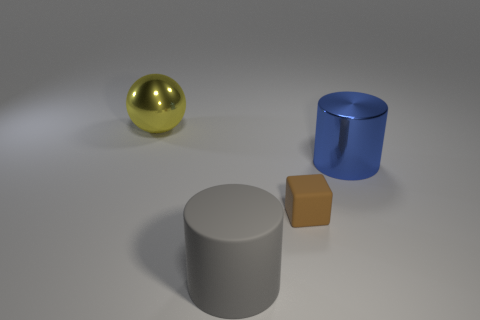Are there any other things that are the same shape as the tiny object?
Make the answer very short. No. Are there any other things that are the same size as the brown cube?
Offer a very short reply. No. There is a thing on the left side of the large rubber cylinder that is in front of the cube; are there any large gray matte things that are in front of it?
Provide a succinct answer. Yes. Do the cylinder in front of the small brown thing and the cylinder that is right of the tiny block have the same material?
Your answer should be compact. No. How many objects are either large things or large cylinders that are on the right side of the gray matte thing?
Ensure brevity in your answer.  3. What number of big blue objects are the same shape as the large yellow object?
Your answer should be very brief. 0. What is the material of the other cylinder that is the same size as the rubber cylinder?
Ensure brevity in your answer.  Metal. There is a metal thing that is in front of the large metal thing behind the large metallic thing that is right of the yellow ball; what is its size?
Give a very brief answer. Large. What number of cyan things are either metallic cylinders or big metal spheres?
Offer a terse response. 0. What number of gray things have the same size as the blue metal cylinder?
Give a very brief answer. 1. 